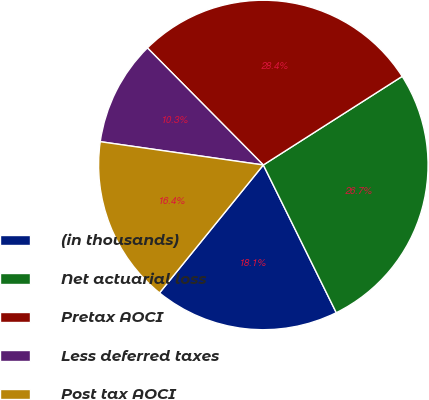Convert chart. <chart><loc_0><loc_0><loc_500><loc_500><pie_chart><fcel>(in thousands)<fcel>Net actuarial loss<fcel>Pretax AOCI<fcel>Less deferred taxes<fcel>Post tax AOCI<nl><fcel>18.15%<fcel>26.74%<fcel>28.38%<fcel>10.32%<fcel>16.41%<nl></chart> 